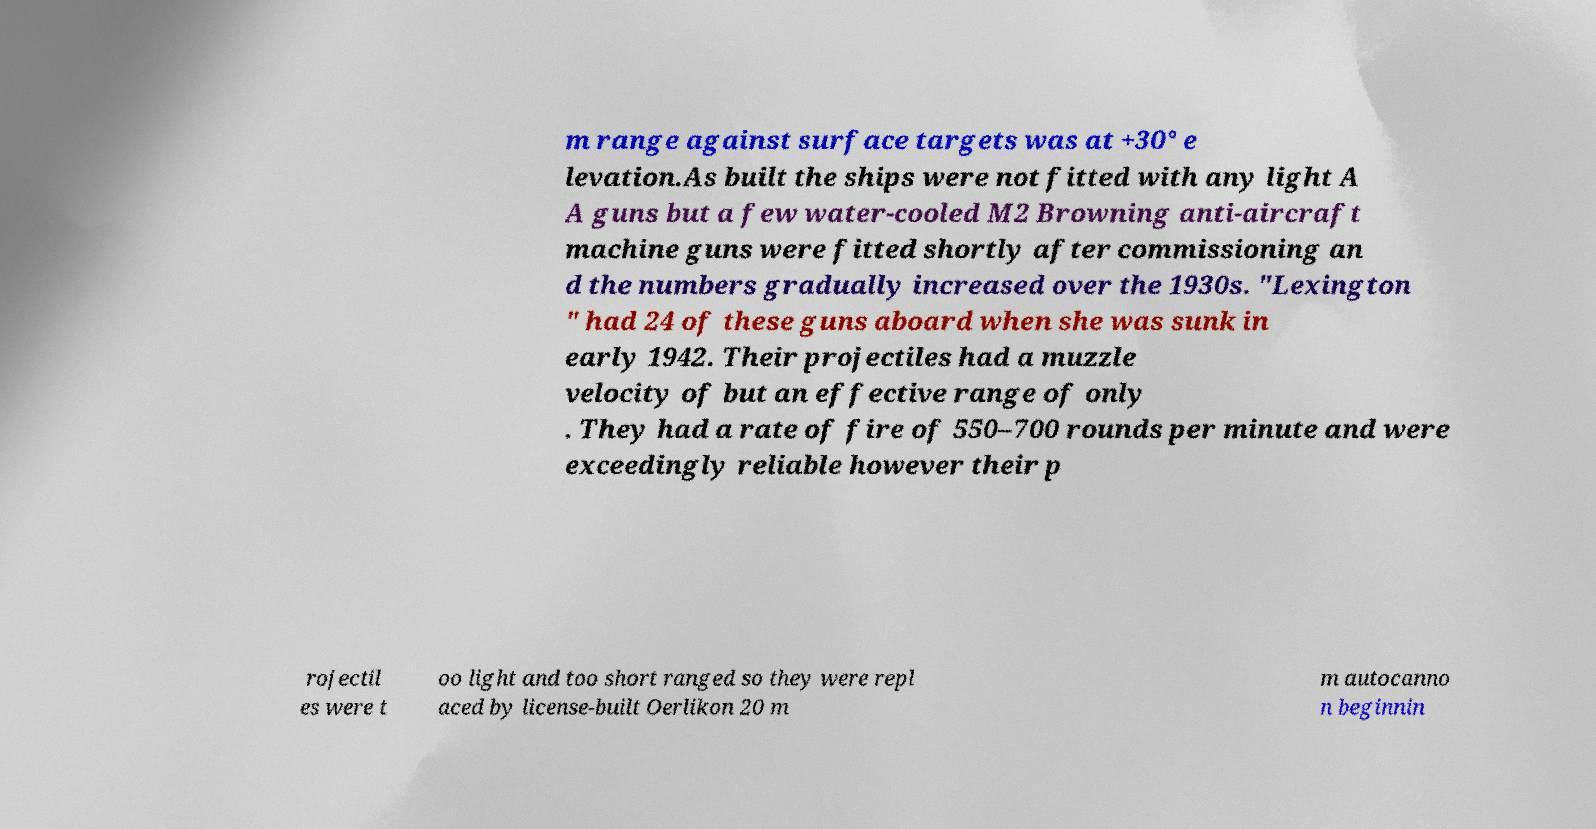There's text embedded in this image that I need extracted. Can you transcribe it verbatim? m range against surface targets was at +30° e levation.As built the ships were not fitted with any light A A guns but a few water-cooled M2 Browning anti-aircraft machine guns were fitted shortly after commissioning an d the numbers gradually increased over the 1930s. "Lexington " had 24 of these guns aboard when she was sunk in early 1942. Their projectiles had a muzzle velocity of but an effective range of only . They had a rate of fire of 550–700 rounds per minute and were exceedingly reliable however their p rojectil es were t oo light and too short ranged so they were repl aced by license-built Oerlikon 20 m m autocanno n beginnin 